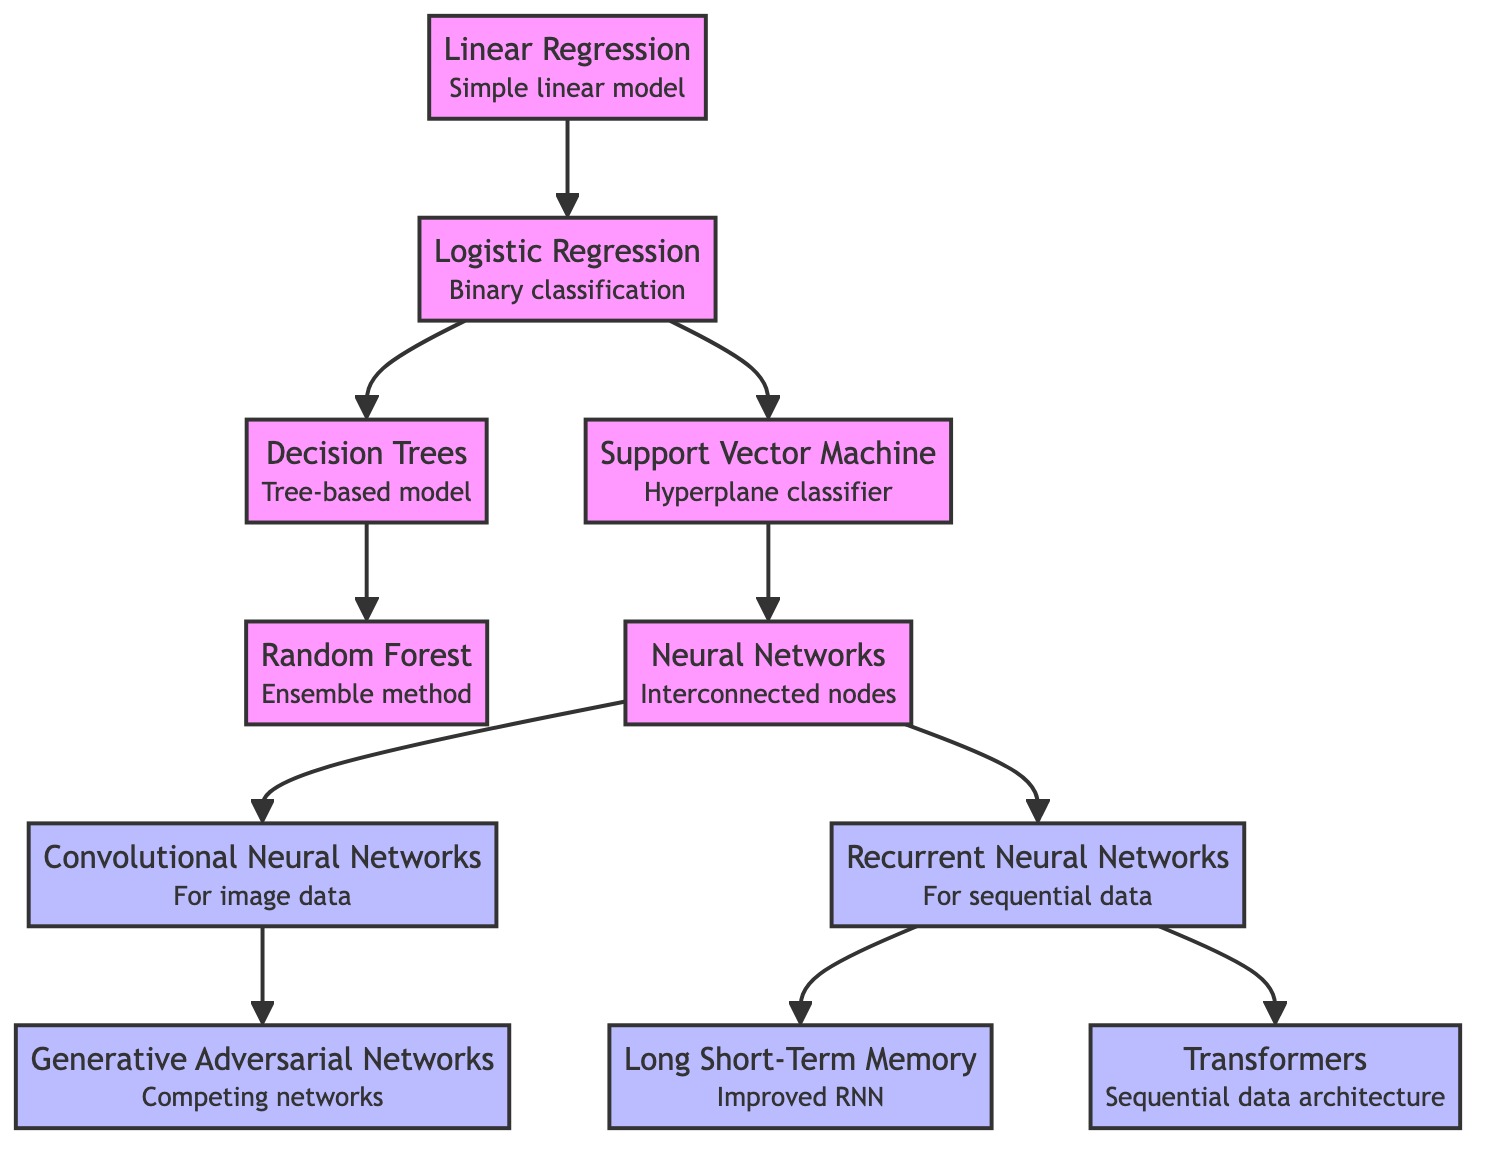What is the first algorithm mentioned in the diagram? The diagram starts with the "Linear Regression" node, which is at the top of the flowchart and indicates it is the initial algorithm in the evolution sequence.
Answer: Linear Regression How many advanced algorithms are represented in the diagram? The advanced algorithms are represented by the nodes "Convolutional Neural Networks," "Recurrent Neural Networks," "Long Short-Term Memory," "Generative Adversarial Networks," and "Transformers." Counting these, there are five advanced algorithms in total.
Answer: 5 Which algorithm directly follows Decision Trees in the flow? Following Decision Trees in the diagram, the next node is "Random Forest." This indicates a direct progression from Decision Trees to Random Forest.
Answer: Random Forest From which algorithm does Support Vector Machine branch? The "Support Vector Machine" algorithm branches from "Logistic Regression," as indicated by the arrow in the diagram that shows the flow from Logistic Regression to SVM.
Answer: Logistic Regression What is the connection between Neural Networks and Convolutional Neural Networks? In the diagram, "Convolutional Neural Networks" (CNN) directly follows "Neural Networks" (NN), indicating that CNN is a specialized type of NN, tailored for processing image data.
Answer: Convolutional Neural Networks Which algorithm is described as an improved RNN? The "Long Short-Term Memory" (LSTM) node is specified to be an improved version of Recurrent Neural Networks (RNN), as indicated by their direct link in the flowchart.
Answer: Long Short-Term Memory How many nodes are connected to the Neural Networks node? The "Neural Networks" node connects to two subsequent nodes: "Convolutional Neural Networks" and "Recurrent Neural Networks." Therefore, there are two nodes extending from Neural Networks.
Answer: 2 What is the last algorithm in the evolutionary chain of the diagram? The last algorithm is "Transformers," which is positioned at the end of its branch and indicates the most advanced stage in this sequence of machine learning evolution.
Answer: Transformers Identify the relationship between the Random Forest and Decision Trees. "Random Forest" depends on "Decision Trees," as shown in the diagram where there is a direct arrow leading from Decision Trees to Random Forest, indicating that Random Forest is built upon multiple Decision Trees.
Answer: Ensemble method 